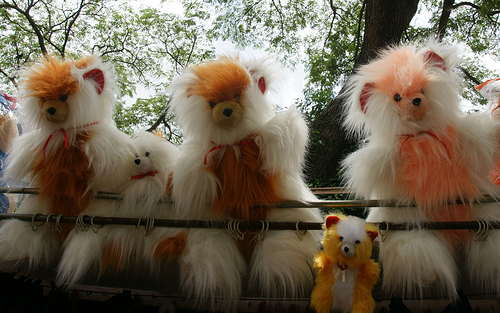<image>What kind of animals are these stuffed animals emulating? I am not sure what kind of animals these stuffed animals are emulating. It can be bears, monkeys, or dogs. What kind of animals are these stuffed animals emulating? I don't know what kind of animals these stuffed animals are emulating. It can be bears, monkeys or dogs. 